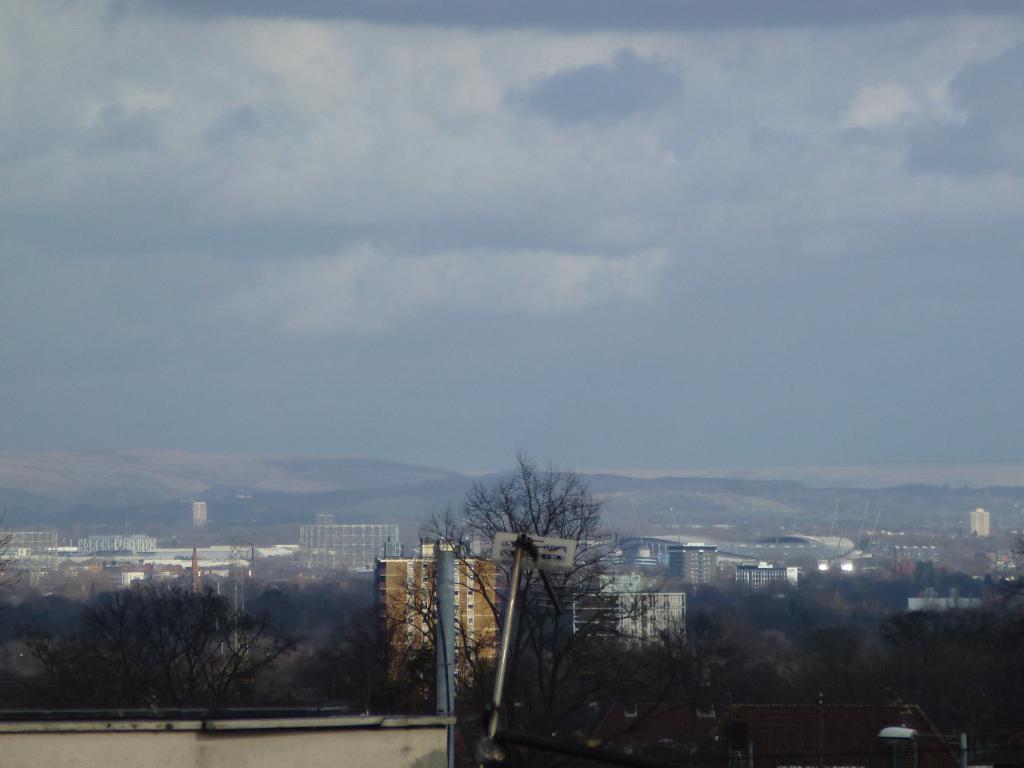How would you summarize this image in a sentence or two? In this image, we can see a cloudy sky, few mountains. At the bottom, there are so many trees, buildings, poles we can see. 